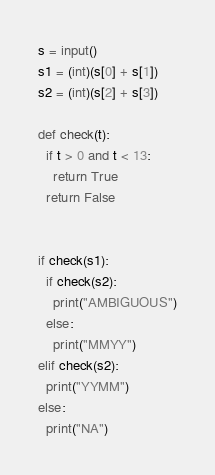Convert code to text. <code><loc_0><loc_0><loc_500><loc_500><_Python_>s = input()
s1 = (int)(s[0] + s[1])
s2 = (int)(s[2] + s[3])

def check(t):
  if t > 0 and t < 13:
    return True
  return False


if check(s1):
  if check(s2):
    print("AMBIGUOUS")
  else:
    print("MMYY")
elif check(s2):
  print("YYMM")
else:
  print("NA")</code> 